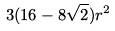Convert formula to latex. <formula><loc_0><loc_0><loc_500><loc_500>3 ( 1 6 - 8 \sqrt { 2 } ) r ^ { 2 }</formula> 